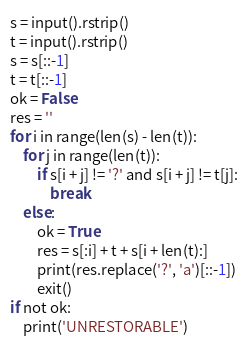<code> <loc_0><loc_0><loc_500><loc_500><_Python_>s = input().rstrip()
t = input().rstrip()
s = s[::-1]
t = t[::-1]
ok = False
res = ''
for i in range(len(s) - len(t)):
    for j in range(len(t)):
        if s[i + j] != '?' and s[i + j] != t[j]:
            break
    else:
        ok = True
        res = s[:i] + t + s[i + len(t):]
        print(res.replace('?', 'a')[::-1])
        exit()
if not ok:
    print('UNRESTORABLE')</code> 